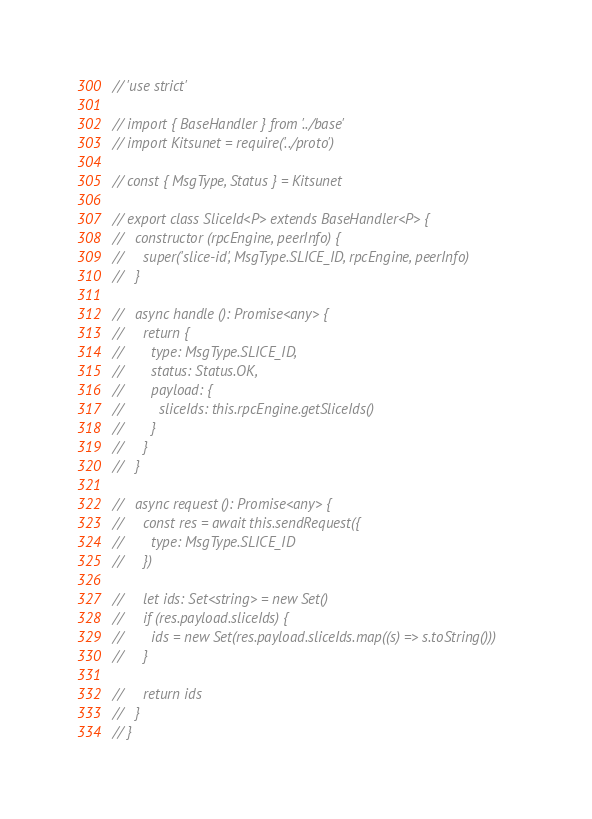Convert code to text. <code><loc_0><loc_0><loc_500><loc_500><_TypeScript_>// 'use strict'

// import { BaseHandler } from '../base'
// import Kitsunet = require('../proto')

// const { MsgType, Status } = Kitsunet

// export class SliceId<P> extends BaseHandler<P> {
//   constructor (rpcEngine, peerInfo) {
//     super('slice-id', MsgType.SLICE_ID, rpcEngine, peerInfo)
//   }

//   async handle (): Promise<any> {
//     return {
//       type: MsgType.SLICE_ID,
//       status: Status.OK,
//       payload: {
//         sliceIds: this.rpcEngine.getSliceIds()
//       }
//     }
//   }

//   async request (): Promise<any> {
//     const res = await this.sendRequest({
//       type: MsgType.SLICE_ID
//     })

//     let ids: Set<string> = new Set()
//     if (res.payload.sliceIds) {
//       ids = new Set(res.payload.sliceIds.map((s) => s.toString()))
//     }

//     return ids
//   }
// }
</code> 